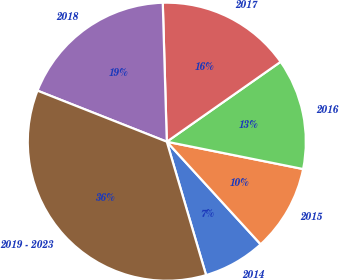Convert chart to OTSL. <chart><loc_0><loc_0><loc_500><loc_500><pie_chart><fcel>2014<fcel>2015<fcel>2016<fcel>2017<fcel>2018<fcel>2019 - 2023<nl><fcel>7.23%<fcel>10.06%<fcel>12.89%<fcel>15.72%<fcel>18.55%<fcel>35.54%<nl></chart> 